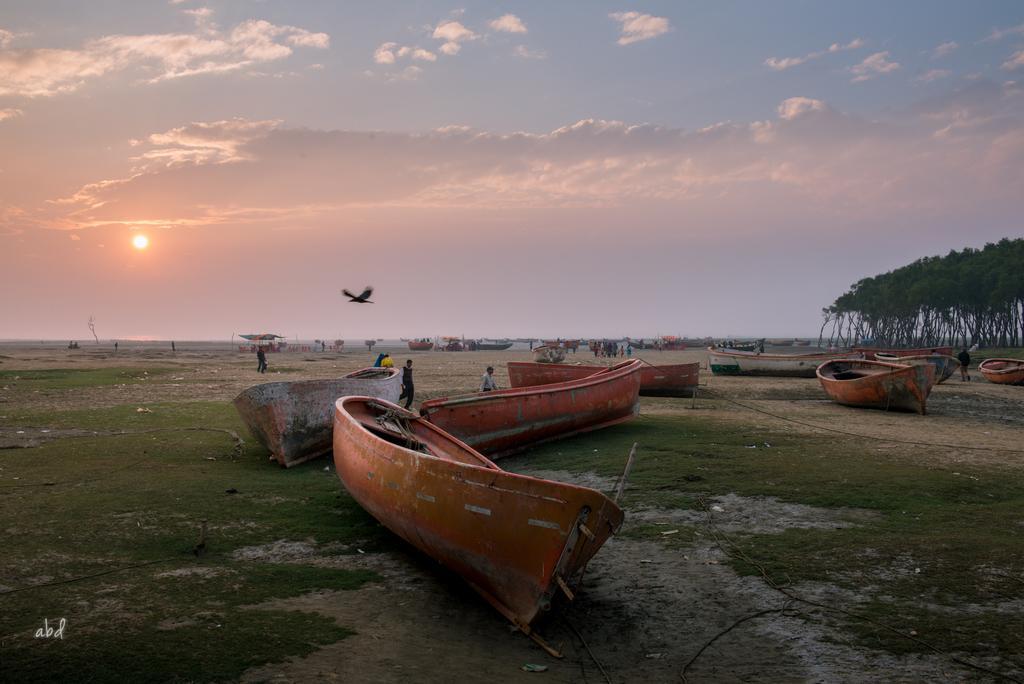How would you summarize this image in a sentence or two? On the bottom left, there is a watermark. In the middle of this image, there are boats on the ground, on which there is grass and there are persons. In the background, there are trees, boats, a bird flying in the air, and there is a sun and there are clouds in the blue sky. 